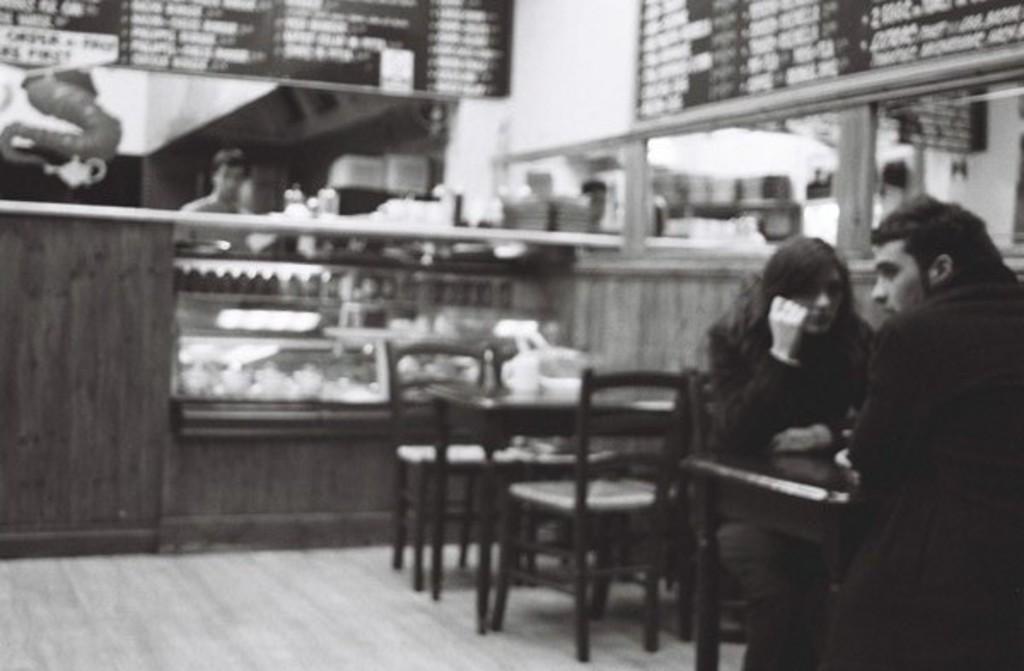Describe this image in one or two sentences. There is a restaurant. There are three people. On the right side persons sitting in a chair. In the top left person is standing. There is a table. There is a glass on a table. We can see in the background there is a cupboard,food items. 